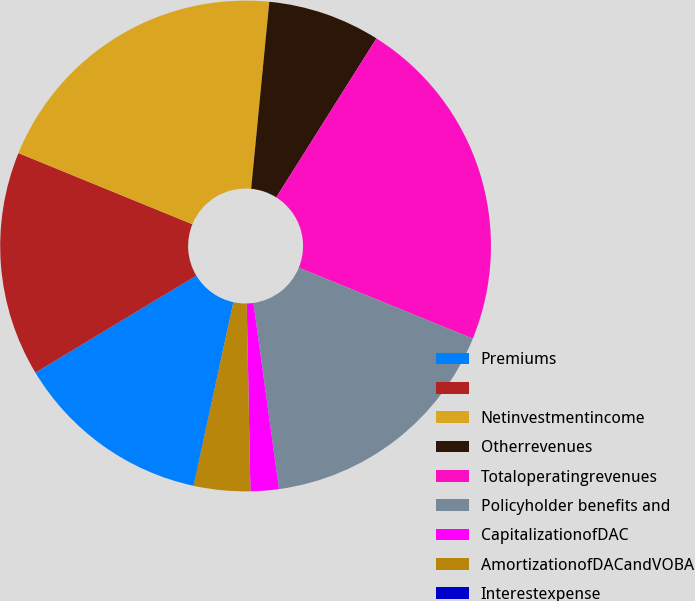<chart> <loc_0><loc_0><loc_500><loc_500><pie_chart><fcel>Premiums<fcel>Unnamed: 1<fcel>Netinvestmentincome<fcel>Otherrevenues<fcel>Totaloperatingrevenues<fcel>Policyholder benefits and<fcel>CapitalizationofDAC<fcel>AmortizationofDACandVOBA<fcel>Interestexpense<nl><fcel>12.96%<fcel>14.81%<fcel>20.36%<fcel>7.41%<fcel>22.21%<fcel>16.66%<fcel>1.86%<fcel>3.71%<fcel>0.01%<nl></chart> 